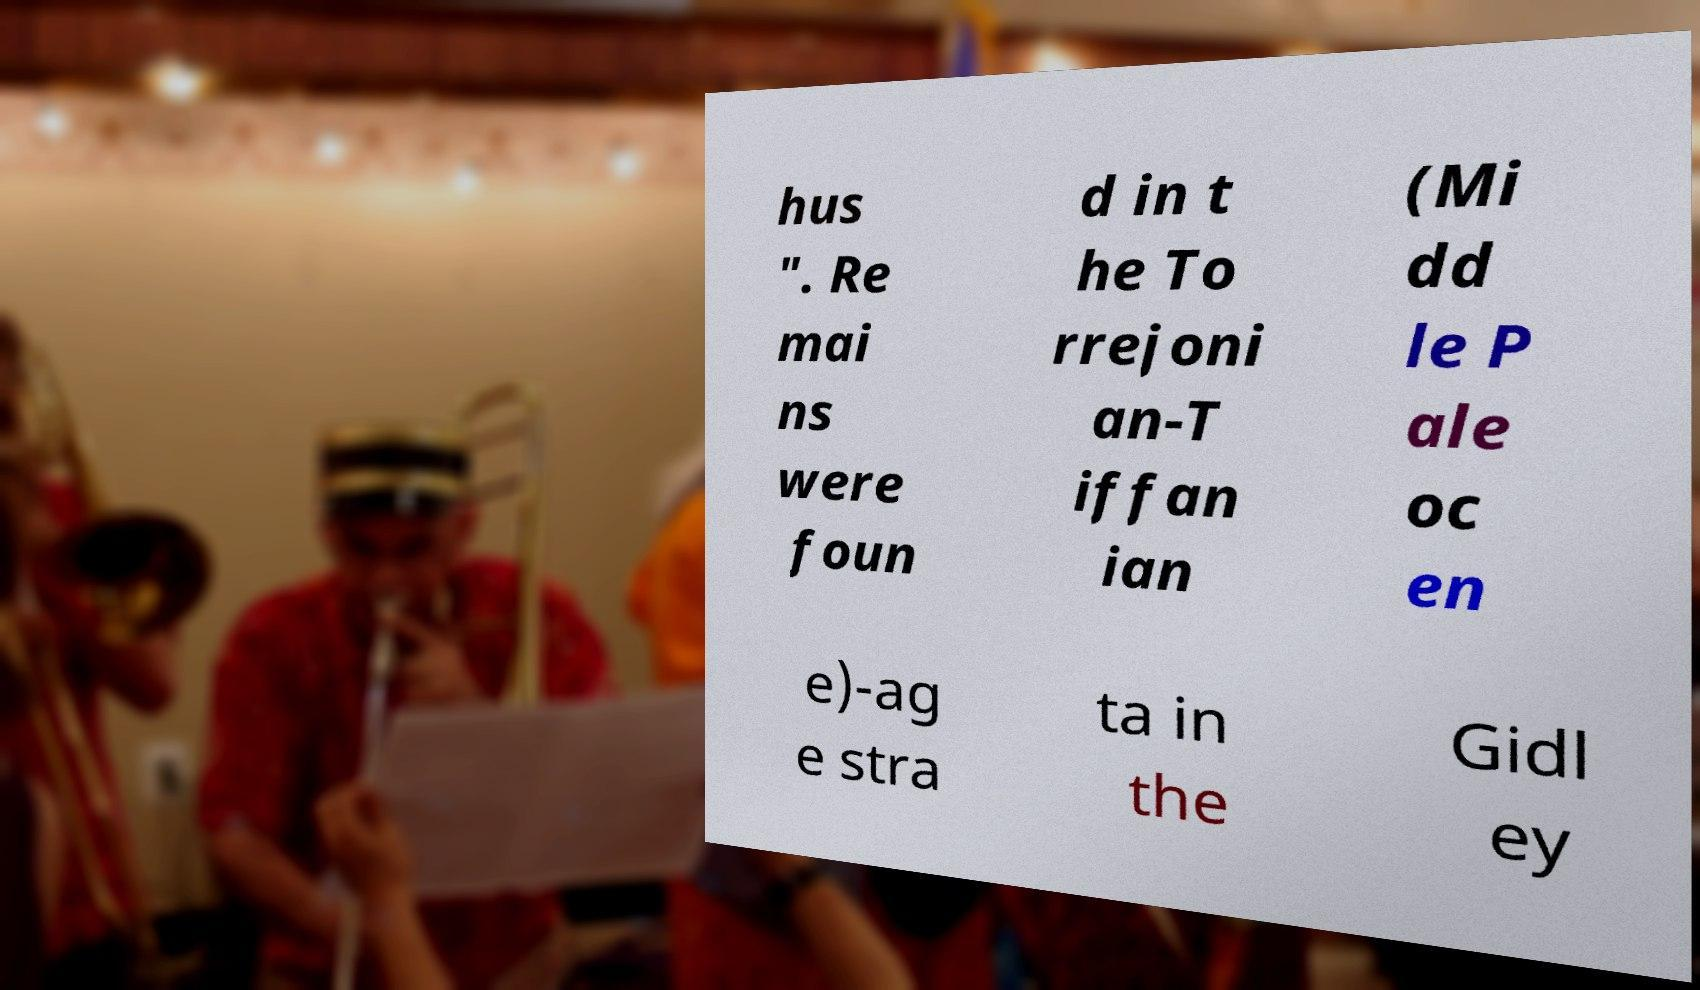Could you assist in decoding the text presented in this image and type it out clearly? hus ". Re mai ns were foun d in t he To rrejoni an-T iffan ian (Mi dd le P ale oc en e)-ag e stra ta in the Gidl ey 